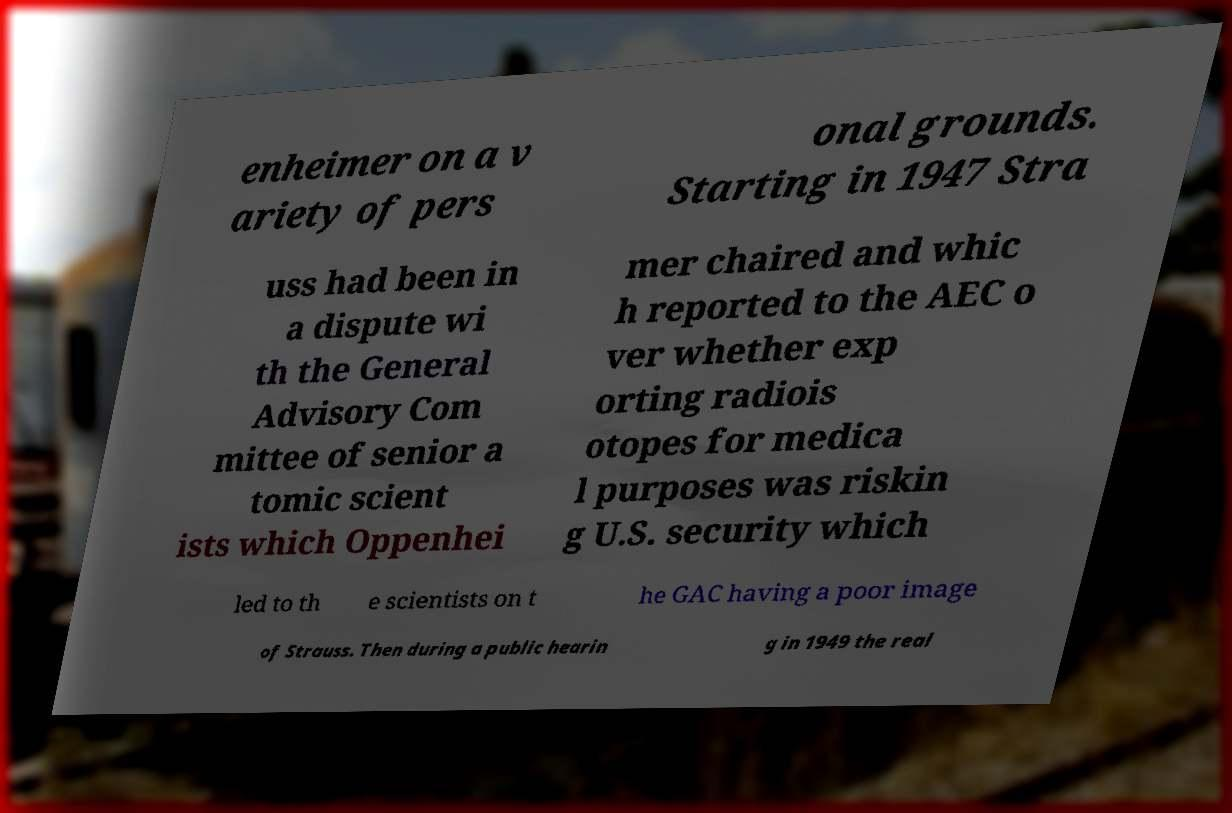Please identify and transcribe the text found in this image. enheimer on a v ariety of pers onal grounds. Starting in 1947 Stra uss had been in a dispute wi th the General Advisory Com mittee of senior a tomic scient ists which Oppenhei mer chaired and whic h reported to the AEC o ver whether exp orting radiois otopes for medica l purposes was riskin g U.S. security which led to th e scientists on t he GAC having a poor image of Strauss. Then during a public hearin g in 1949 the real 